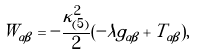Convert formula to latex. <formula><loc_0><loc_0><loc_500><loc_500>W _ { \alpha \beta } = - \frac { \kappa _ { ( 5 ) } ^ { 2 } } { 2 } ( - \lambda g _ { \alpha \beta } + T _ { \alpha \beta } ) ,</formula> 